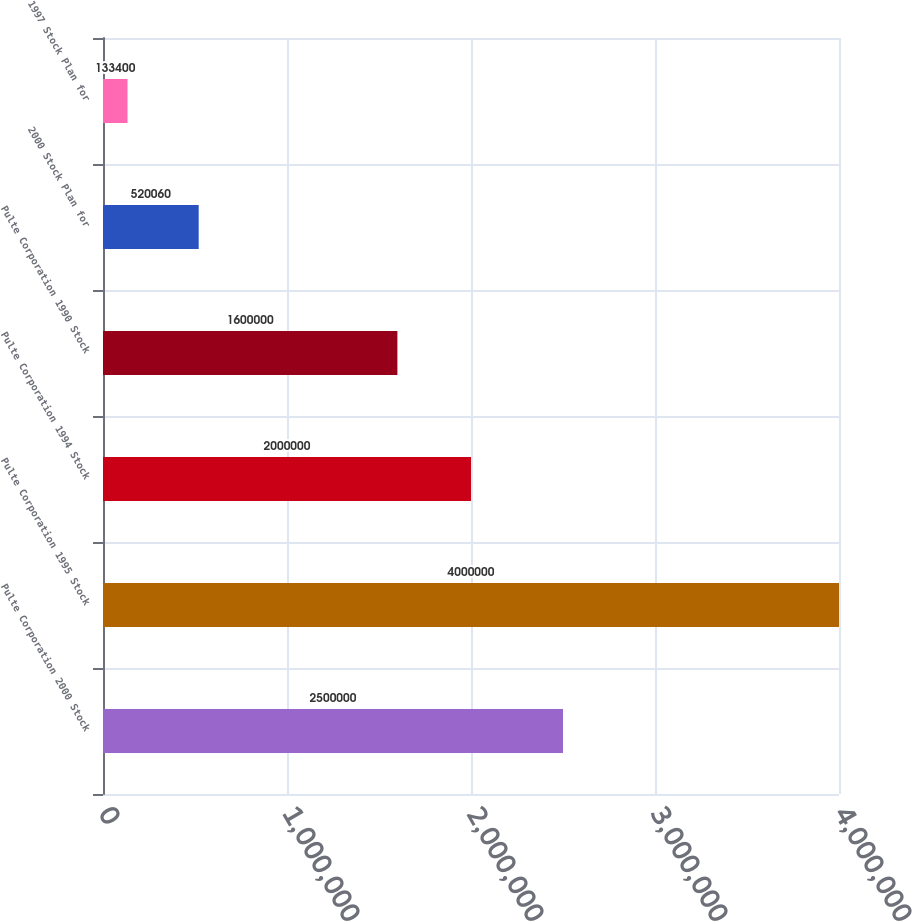<chart> <loc_0><loc_0><loc_500><loc_500><bar_chart><fcel>Pulte Corporation 2000 Stock<fcel>Pulte Corporation 1995 Stock<fcel>Pulte Corporation 1994 Stock<fcel>Pulte Corporation 1990 Stock<fcel>2000 Stock Plan for<fcel>1997 Stock Plan for<nl><fcel>2.5e+06<fcel>4e+06<fcel>2e+06<fcel>1.6e+06<fcel>520060<fcel>133400<nl></chart> 